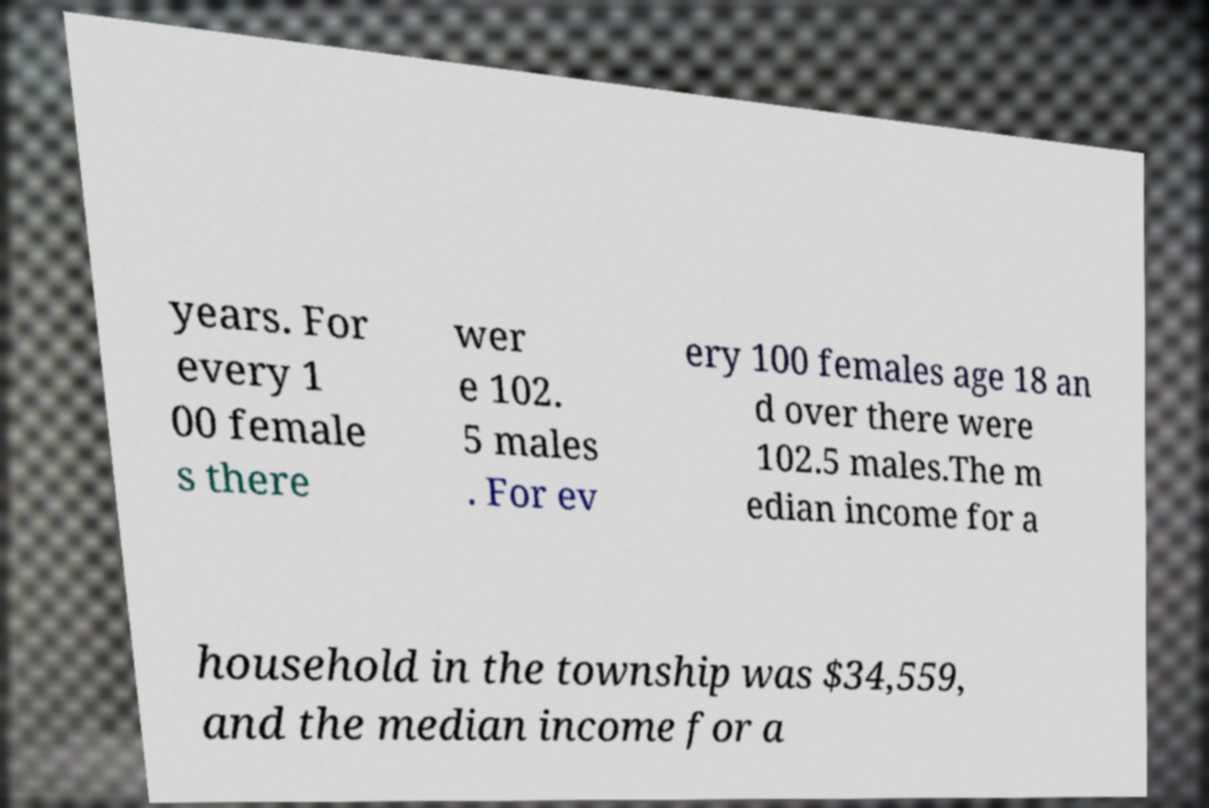Can you accurately transcribe the text from the provided image for me? years. For every 1 00 female s there wer e 102. 5 males . For ev ery 100 females age 18 an d over there were 102.5 males.The m edian income for a household in the township was $34,559, and the median income for a 